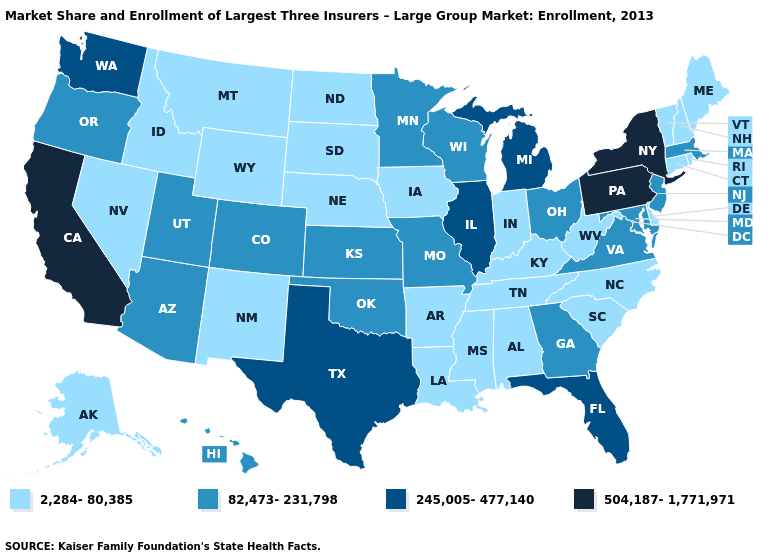What is the lowest value in the MidWest?
Answer briefly. 2,284-80,385. What is the value of Georgia?
Concise answer only. 82,473-231,798. Name the states that have a value in the range 245,005-477,140?
Write a very short answer. Florida, Illinois, Michigan, Texas, Washington. What is the value of South Carolina?
Write a very short answer. 2,284-80,385. How many symbols are there in the legend?
Answer briefly. 4. Among the states that border Pennsylvania , which have the lowest value?
Concise answer only. Delaware, West Virginia. Does the map have missing data?
Quick response, please. No. Is the legend a continuous bar?
Answer briefly. No. Does New Jersey have the lowest value in the Northeast?
Be succinct. No. What is the value of Virginia?
Answer briefly. 82,473-231,798. How many symbols are there in the legend?
Keep it brief. 4. Name the states that have a value in the range 245,005-477,140?
Be succinct. Florida, Illinois, Michigan, Texas, Washington. Which states have the lowest value in the USA?
Be succinct. Alabama, Alaska, Arkansas, Connecticut, Delaware, Idaho, Indiana, Iowa, Kentucky, Louisiana, Maine, Mississippi, Montana, Nebraska, Nevada, New Hampshire, New Mexico, North Carolina, North Dakota, Rhode Island, South Carolina, South Dakota, Tennessee, Vermont, West Virginia, Wyoming. What is the highest value in the USA?
Short answer required. 504,187-1,771,971. Among the states that border Vermont , does New York have the lowest value?
Keep it brief. No. 